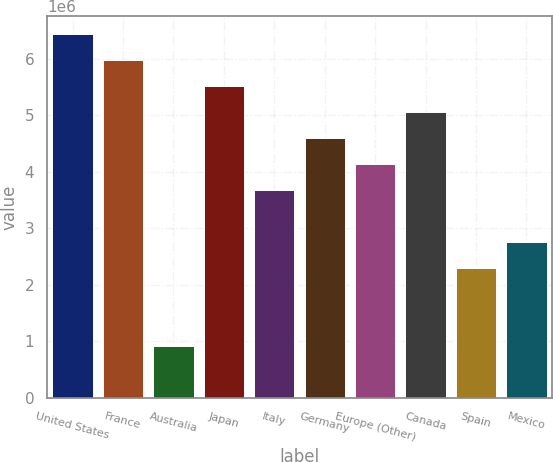Convert chart. <chart><loc_0><loc_0><loc_500><loc_500><bar_chart><fcel>United States<fcel>France<fcel>Australia<fcel>Japan<fcel>Italy<fcel>Germany<fcel>Europe (Other)<fcel>Canada<fcel>Spain<fcel>Mexico<nl><fcel>6.43086e+06<fcel>5.97181e+06<fcel>922277<fcel>5.51276e+06<fcel>3.67657e+06<fcel>4.59466e+06<fcel>4.13562e+06<fcel>5.05371e+06<fcel>2.29942e+06<fcel>2.75847e+06<nl></chart> 